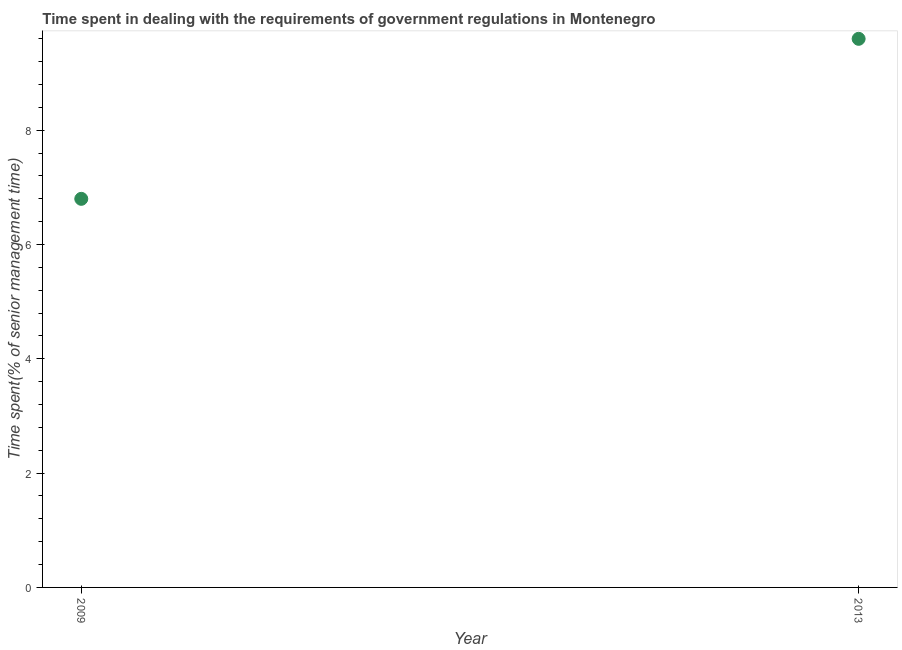Across all years, what is the maximum time spent in dealing with government regulations?
Make the answer very short. 9.6. Across all years, what is the minimum time spent in dealing with government regulations?
Keep it short and to the point. 6.8. In which year was the time spent in dealing with government regulations maximum?
Give a very brief answer. 2013. In which year was the time spent in dealing with government regulations minimum?
Offer a terse response. 2009. What is the sum of the time spent in dealing with government regulations?
Provide a succinct answer. 16.4. In how many years, is the time spent in dealing with government regulations greater than 6.4 %?
Keep it short and to the point. 2. What is the ratio of the time spent in dealing with government regulations in 2009 to that in 2013?
Your answer should be compact. 0.71. How many dotlines are there?
Your response must be concise. 1. Are the values on the major ticks of Y-axis written in scientific E-notation?
Give a very brief answer. No. Does the graph contain any zero values?
Offer a very short reply. No. What is the title of the graph?
Give a very brief answer. Time spent in dealing with the requirements of government regulations in Montenegro. What is the label or title of the X-axis?
Keep it short and to the point. Year. What is the label or title of the Y-axis?
Ensure brevity in your answer.  Time spent(% of senior management time). What is the Time spent(% of senior management time) in 2009?
Your answer should be very brief. 6.8. What is the Time spent(% of senior management time) in 2013?
Ensure brevity in your answer.  9.6. What is the difference between the Time spent(% of senior management time) in 2009 and 2013?
Make the answer very short. -2.8. What is the ratio of the Time spent(% of senior management time) in 2009 to that in 2013?
Your answer should be very brief. 0.71. 